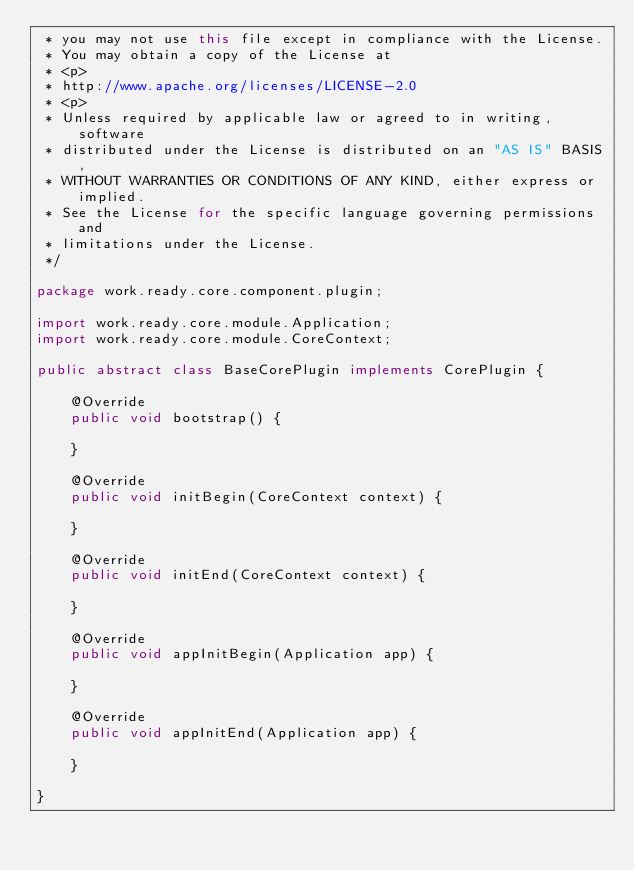<code> <loc_0><loc_0><loc_500><loc_500><_Java_> * you may not use this file except in compliance with the License.
 * You may obtain a copy of the License at
 * <p>
 * http://www.apache.org/licenses/LICENSE-2.0
 * <p>
 * Unless required by applicable law or agreed to in writing, software
 * distributed under the License is distributed on an "AS IS" BASIS,
 * WITHOUT WARRANTIES OR CONDITIONS OF ANY KIND, either express or implied.
 * See the License for the specific language governing permissions and
 * limitations under the License.
 */

package work.ready.core.component.plugin;

import work.ready.core.module.Application;
import work.ready.core.module.CoreContext;

public abstract class BaseCorePlugin implements CorePlugin {

    @Override
    public void bootstrap() {

    }

    @Override
    public void initBegin(CoreContext context) {

    }

    @Override
    public void initEnd(CoreContext context) {

    }

    @Override
    public void appInitBegin(Application app) {

    }

    @Override
    public void appInitEnd(Application app) {

    }

}
</code> 